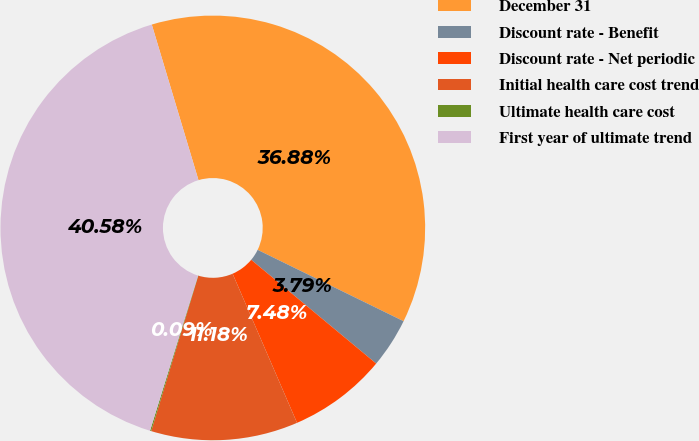Convert chart. <chart><loc_0><loc_0><loc_500><loc_500><pie_chart><fcel>December 31<fcel>Discount rate - Benefit<fcel>Discount rate - Net periodic<fcel>Initial health care cost trend<fcel>Ultimate health care cost<fcel>First year of ultimate trend<nl><fcel>36.88%<fcel>3.79%<fcel>7.48%<fcel>11.18%<fcel>0.09%<fcel>40.58%<nl></chart> 